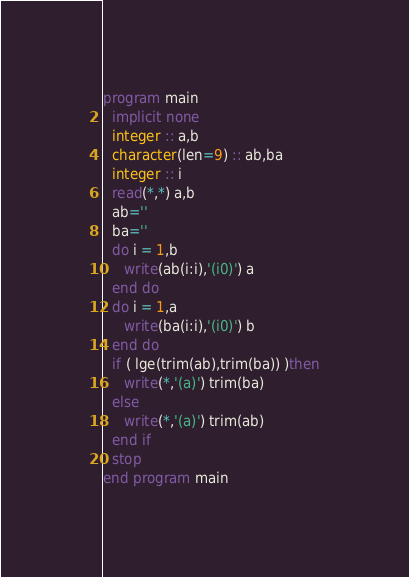Convert code to text. <code><loc_0><loc_0><loc_500><loc_500><_FORTRAN_>program main
  implicit none
  integer :: a,b
  character(len=9) :: ab,ba
  integer :: i
  read(*,*) a,b
  ab=''
  ba=''
  do i = 1,b
     write(ab(i:i),'(i0)') a
  end do
  do i = 1,a
     write(ba(i:i),'(i0)') b
  end do
  if ( lge(trim(ab),trim(ba)) )then
     write(*,'(a)') trim(ba)
  else 
     write(*,'(a)') trim(ab)
  end if
  stop
end program main</code> 